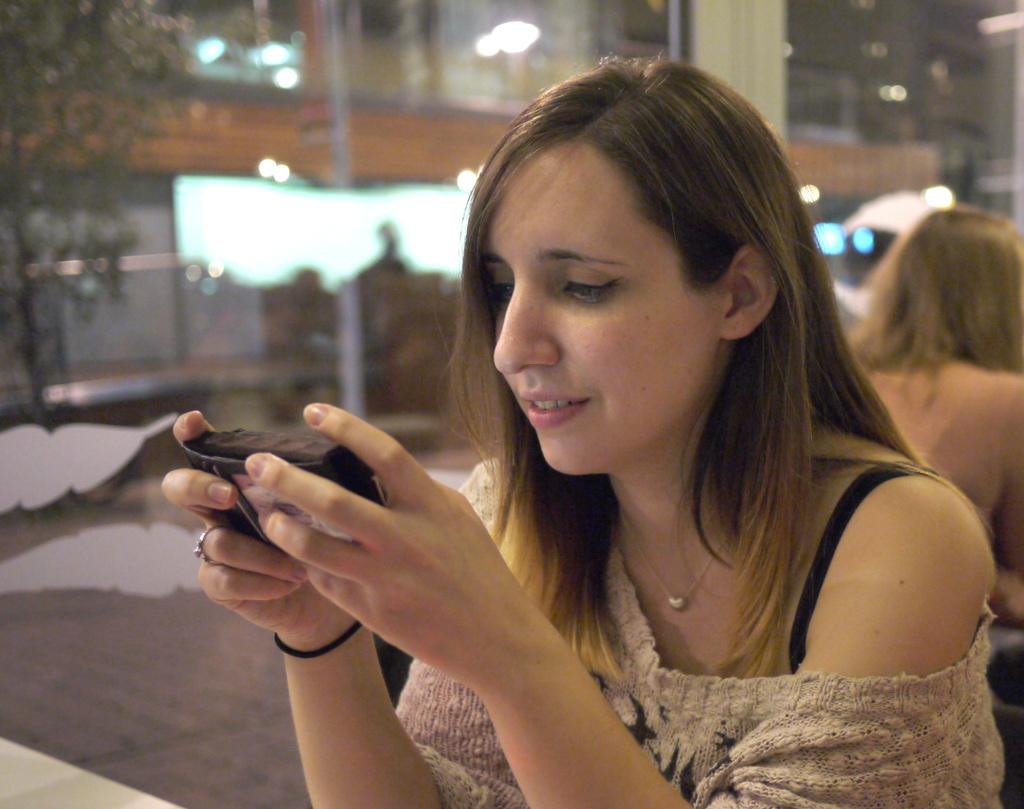What is the woman in the image doing? There is a woman sitting on a chair in the image, and she is holding a camera in her hand. How many women are present in the image? There are two women in the image, both sitting on chairs. What is the woman with the camera possibly doing? The woman with the camera might be taking photographs or preparing to take photographs. What type of cheese is being served by the band in the image? There is no band or cheese present in the image; it only features two women sitting on chairs. 